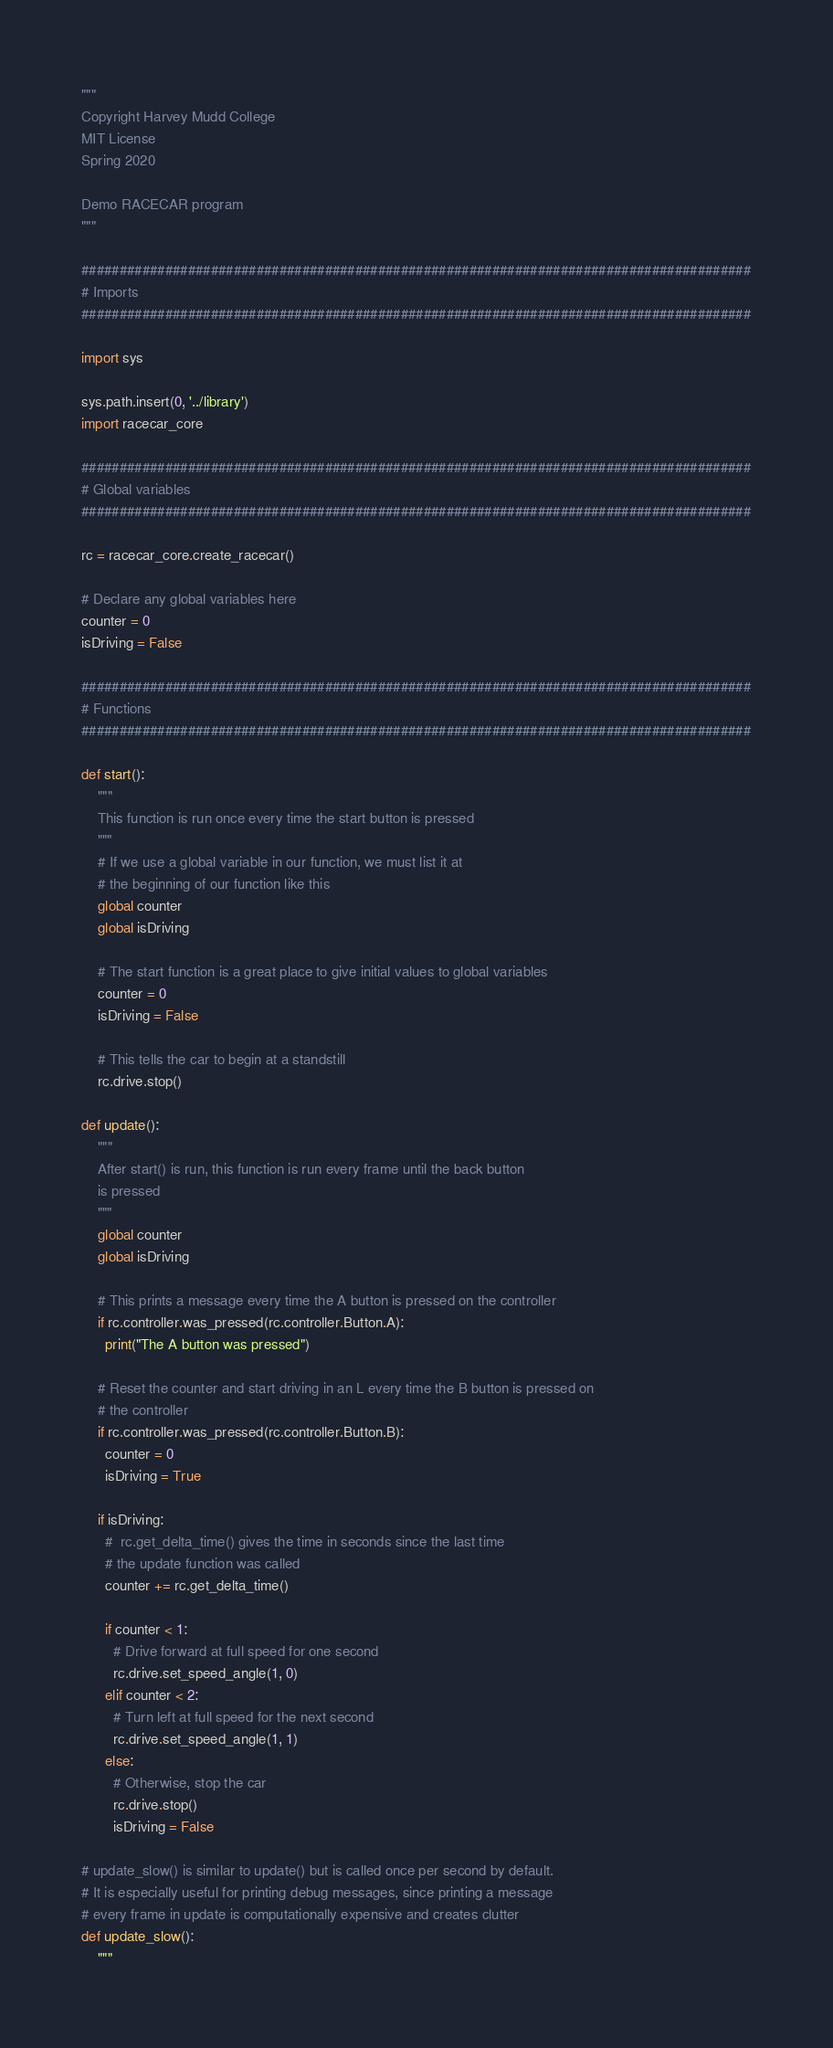<code> <loc_0><loc_0><loc_500><loc_500><_Python_>"""
Copyright Harvey Mudd College
MIT License
Spring 2020

Demo RACECAR program
"""

########################################################################################
# Imports
########################################################################################

import sys

sys.path.insert(0, '../library')
import racecar_core

########################################################################################
# Global variables
########################################################################################

rc = racecar_core.create_racecar()

# Declare any global variables here
counter = 0
isDriving = False

########################################################################################
# Functions
########################################################################################

def start():
    """
    This function is run once every time the start button is pressed
    """
    # If we use a global variable in our function, we must list it at
    # the beginning of our function like this
    global counter
    global isDriving

    # The start function is a great place to give initial values to global variables
    counter = 0
    isDriving = False

    # This tells the car to begin at a standstill
    rc.drive.stop()

def update():
    """
    After start() is run, this function is run every frame until the back button
    is pressed
    """
    global counter
    global isDriving

    # This prints a message every time the A button is pressed on the controller
    if rc.controller.was_pressed(rc.controller.Button.A):
      print("The A button was pressed")

    # Reset the counter and start driving in an L every time the B button is pressed on
    # the controller
    if rc.controller.was_pressed(rc.controller.Button.B):
      counter = 0
      isDriving = True

    if isDriving:
      #  rc.get_delta_time() gives the time in seconds since the last time
      # the update function was called
      counter += rc.get_delta_time()

      if counter < 1:
        # Drive forward at full speed for one second
        rc.drive.set_speed_angle(1, 0)
      elif counter < 2:
        # Turn left at full speed for the next second
        rc.drive.set_speed_angle(1, 1)
      else:
        # Otherwise, stop the car
        rc.drive.stop()
        isDriving = False

# update_slow() is similar to update() but is called once per second by default.
# It is especially useful for printing debug messages, since printing a message
# every frame in update is computationally expensive and creates clutter
def update_slow():
    """</code> 